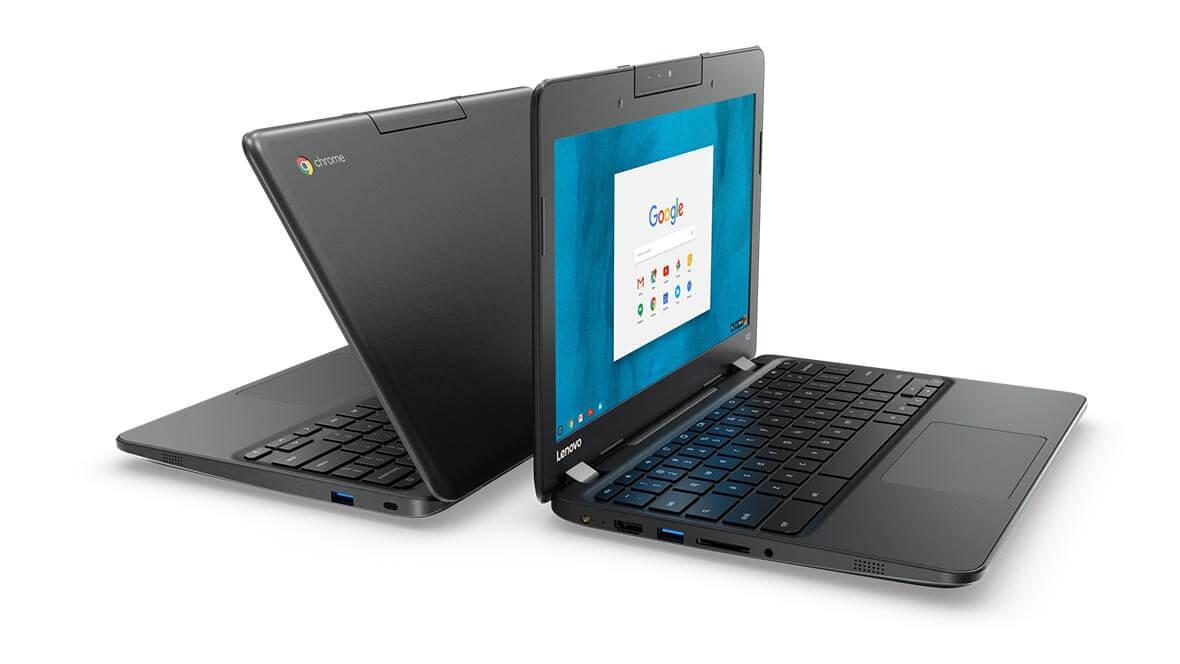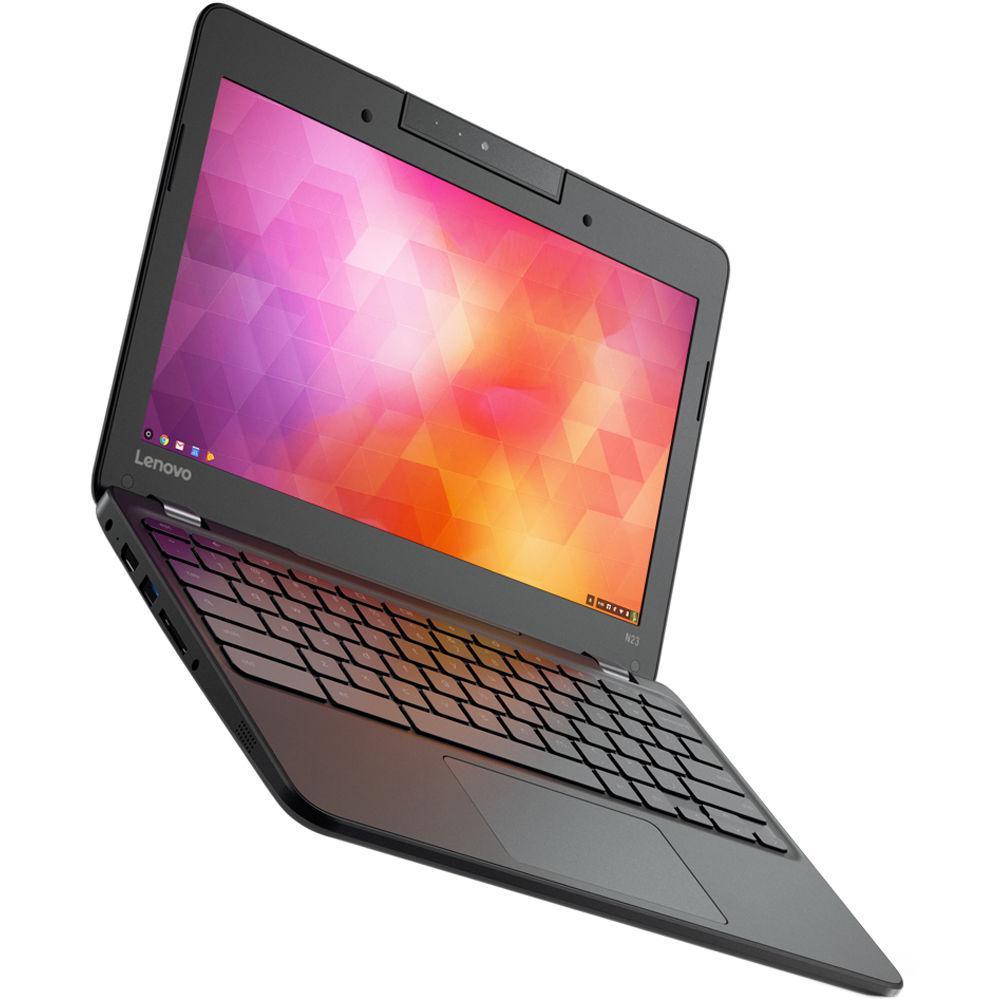The first image is the image on the left, the second image is the image on the right. Evaluate the accuracy of this statement regarding the images: "The combined images include at least three laptops that are open with the screen not inverted.". Is it true? Answer yes or no. Yes. The first image is the image on the left, the second image is the image on the right. Evaluate the accuracy of this statement regarding the images: "There are more computers in the image on the left.". Is it true? Answer yes or no. Yes. 